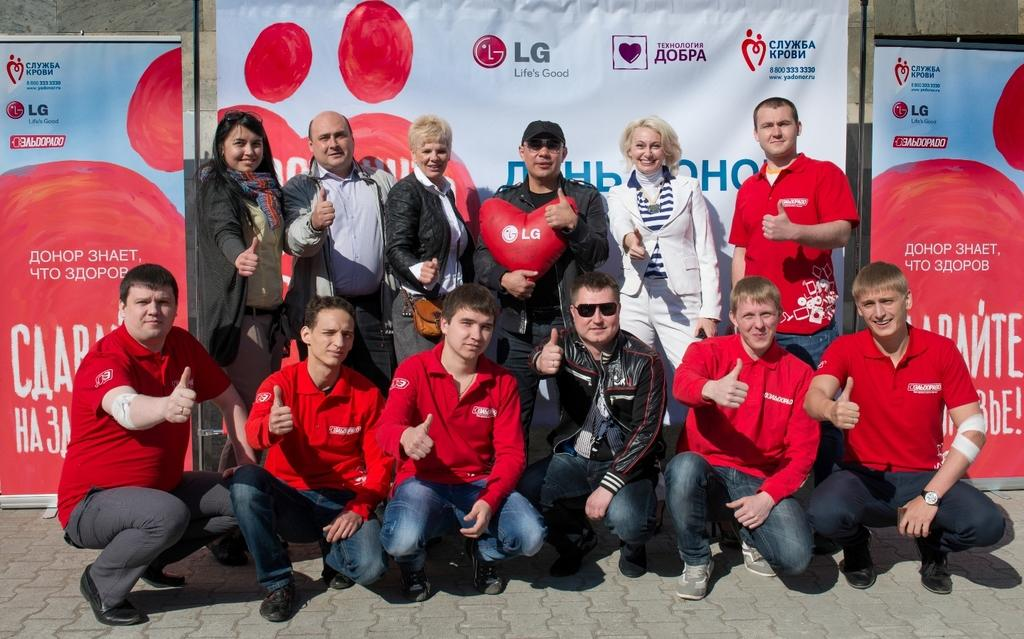What is the main subject of the image? The main subject of the image is a group of people. Where are the people located in the image? The group of people is in the middle of the image. What can be seen in the background of the image? There are banners in the background of the image. What type of street is visible in the image? There is no street visible in the image; it only features a group of people and banners in the background. How many people are laughing in the image? The provided facts do not mention anyone laughing in the image, so it cannot be determined from the image. 